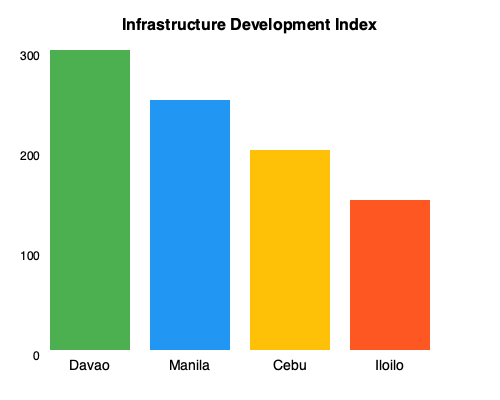Based on the bar chart showing the Infrastructure Development Index for major Philippine cities, how does Davao's infrastructure development compare to other cities, and what factors might contribute to this difference? To answer this question, let's analyze the bar chart step-by-step:

1. Davao's Infrastructure Development Index:
   - Davao has the highest bar, reaching 300 on the scale.

2. Comparison with other cities:
   - Manila: Second highest, reaching about 250 on the scale.
   - Cebu: Third, reaching about 200 on the scale.
   - Iloilo: Lowest, reaching about 150 on the scale.

3. Relative performance:
   - Davao's index is approximately 20% higher than Manila's.
   - Davao's index is about 50% higher than Cebu's.
   - Davao's index is roughly 100% higher than Iloilo's.

4. Factors contributing to Davao's higher index:
   a. Political support: The Marcos family has historically supported development in Mindanao, including Davao.
   b. Strategic location: Davao is the largest city in Mindanao, serving as an economic hub.
   c. Local leadership: Effective local governance, including the tenure of former Mayor Rodrigo Duterte.
   d. Investment attraction: Policies encouraging both local and foreign investments in infrastructure.
   e. Urban planning: Implementation of long-term development plans focusing on infrastructure.

5. Implications:
   - Davao's higher infrastructure development index suggests better overall urban development, potentially leading to improved quality of life and economic opportunities for residents.

The data indicates that Davao has significantly outperformed other major Philippine cities in terms of infrastructure development, likely due to a combination of political support, strategic importance, and effective local governance.
Answer: Davao's infrastructure development index is highest, exceeding other major cities by 20-100%, potentially due to political support, strategic location, effective governance, and focused urban planning. 